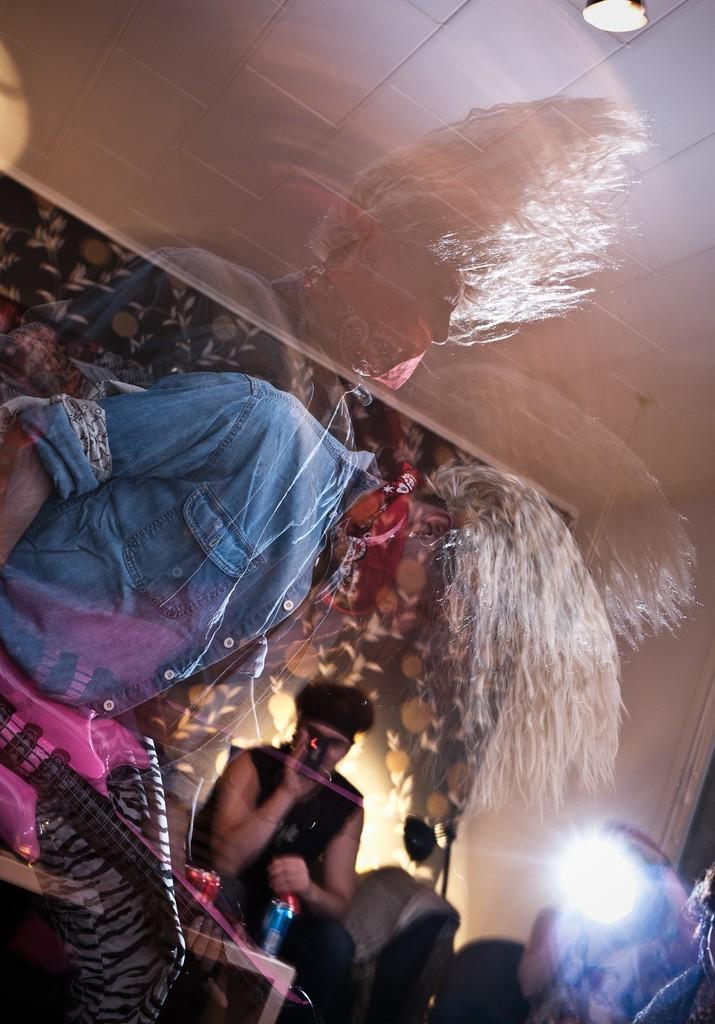What is the person in the image wearing? The person is wearing a jeans jacket in the image. What is the person holding in the image? The person is holding a guitar in the image. What is happening in the background of the image? There is a man singing in the background of the image. What architectural feature is visible in the image? There is a roof visible in the image. What is located to the right of the image? There is a wall to the right of the image. How many ladybugs can be seen on the guitar in the image? There are no ladybugs visible on the guitar in the image. What type of deer is present in the image? There are no deer present in the image. 